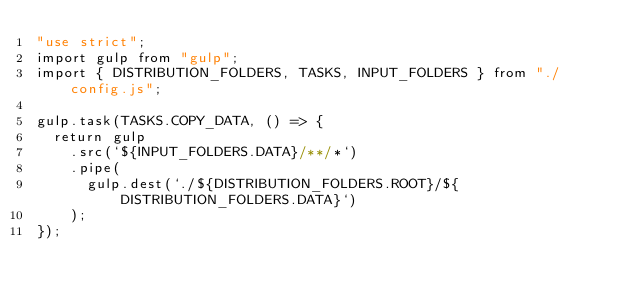<code> <loc_0><loc_0><loc_500><loc_500><_JavaScript_>"use strict";
import gulp from "gulp";
import { DISTRIBUTION_FOLDERS, TASKS, INPUT_FOLDERS } from "./config.js";

gulp.task(TASKS.COPY_DATA, () => {
  return gulp
    .src(`${INPUT_FOLDERS.DATA}/**/*`)
    .pipe(
      gulp.dest(`./${DISTRIBUTION_FOLDERS.ROOT}/${DISTRIBUTION_FOLDERS.DATA}`)
    );
});
</code> 